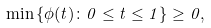<formula> <loc_0><loc_0><loc_500><loc_500>\min \left \{ \phi ( t ) \colon 0 \leq t \leq 1 \right \} \geq 0 ,</formula> 